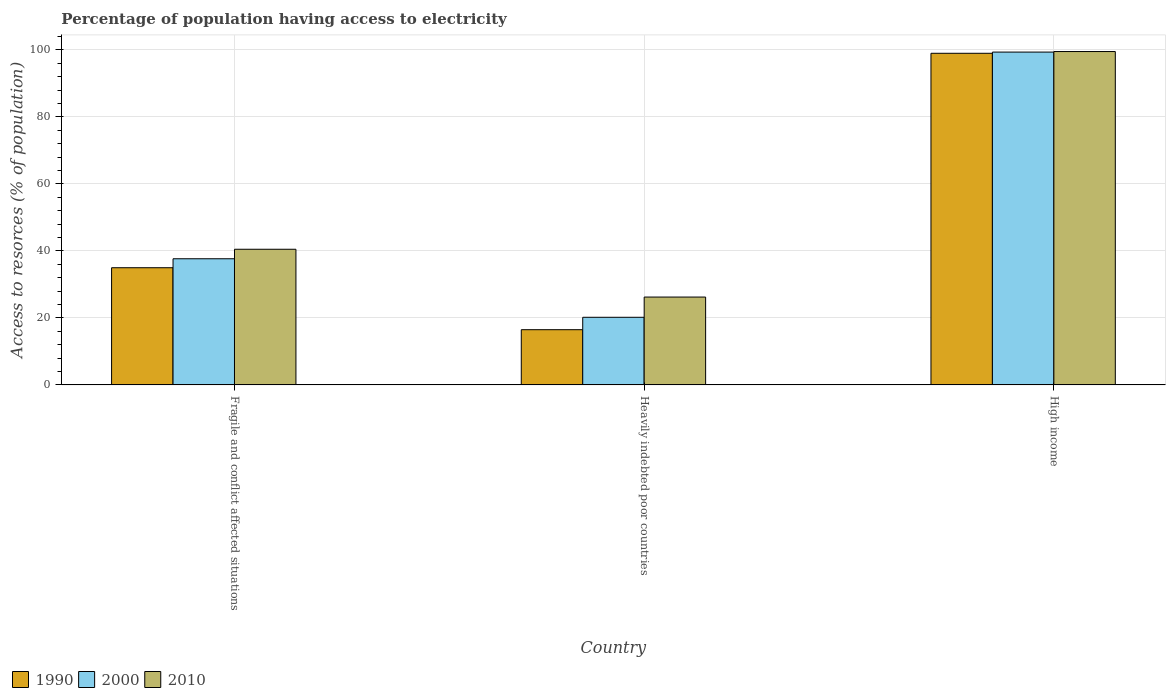How many different coloured bars are there?
Offer a very short reply. 3. How many groups of bars are there?
Provide a succinct answer. 3. Are the number of bars per tick equal to the number of legend labels?
Your answer should be compact. Yes. Are the number of bars on each tick of the X-axis equal?
Provide a short and direct response. Yes. What is the label of the 2nd group of bars from the left?
Offer a very short reply. Heavily indebted poor countries. What is the percentage of population having access to electricity in 2010 in Fragile and conflict affected situations?
Make the answer very short. 40.49. Across all countries, what is the maximum percentage of population having access to electricity in 2000?
Keep it short and to the point. 99.33. Across all countries, what is the minimum percentage of population having access to electricity in 1990?
Keep it short and to the point. 16.48. In which country was the percentage of population having access to electricity in 2000 maximum?
Offer a very short reply. High income. In which country was the percentage of population having access to electricity in 1990 minimum?
Provide a succinct answer. Heavily indebted poor countries. What is the total percentage of population having access to electricity in 1990 in the graph?
Your response must be concise. 150.42. What is the difference between the percentage of population having access to electricity in 1990 in Fragile and conflict affected situations and that in High income?
Your response must be concise. -64. What is the difference between the percentage of population having access to electricity in 2000 in High income and the percentage of population having access to electricity in 2010 in Fragile and conflict affected situations?
Keep it short and to the point. 58.84. What is the average percentage of population having access to electricity in 1990 per country?
Offer a terse response. 50.14. What is the difference between the percentage of population having access to electricity of/in 2010 and percentage of population having access to electricity of/in 1990 in Heavily indebted poor countries?
Your answer should be compact. 9.74. What is the ratio of the percentage of population having access to electricity in 2000 in Heavily indebted poor countries to that in High income?
Your response must be concise. 0.2. What is the difference between the highest and the second highest percentage of population having access to electricity in 2000?
Ensure brevity in your answer.  79.15. What is the difference between the highest and the lowest percentage of population having access to electricity in 2000?
Provide a succinct answer. 79.15. In how many countries, is the percentage of population having access to electricity in 2010 greater than the average percentage of population having access to electricity in 2010 taken over all countries?
Offer a very short reply. 1. What does the 3rd bar from the left in High income represents?
Your response must be concise. 2010. What does the 3rd bar from the right in High income represents?
Your answer should be very brief. 1990. Are all the bars in the graph horizontal?
Your response must be concise. No. Does the graph contain grids?
Offer a terse response. Yes. How many legend labels are there?
Offer a terse response. 3. What is the title of the graph?
Make the answer very short. Percentage of population having access to electricity. What is the label or title of the X-axis?
Your answer should be compact. Country. What is the label or title of the Y-axis?
Ensure brevity in your answer.  Access to resorces (% of population). What is the Access to resorces (% of population) in 1990 in Fragile and conflict affected situations?
Make the answer very short. 34.97. What is the Access to resorces (% of population) of 2000 in Fragile and conflict affected situations?
Offer a terse response. 37.65. What is the Access to resorces (% of population) of 2010 in Fragile and conflict affected situations?
Offer a terse response. 40.49. What is the Access to resorces (% of population) in 1990 in Heavily indebted poor countries?
Provide a short and direct response. 16.48. What is the Access to resorces (% of population) in 2000 in Heavily indebted poor countries?
Your answer should be very brief. 20.18. What is the Access to resorces (% of population) in 2010 in Heavily indebted poor countries?
Offer a terse response. 26.22. What is the Access to resorces (% of population) in 1990 in High income?
Ensure brevity in your answer.  98.97. What is the Access to resorces (% of population) of 2000 in High income?
Give a very brief answer. 99.33. What is the Access to resorces (% of population) of 2010 in High income?
Give a very brief answer. 99.49. Across all countries, what is the maximum Access to resorces (% of population) in 1990?
Provide a short and direct response. 98.97. Across all countries, what is the maximum Access to resorces (% of population) in 2000?
Your response must be concise. 99.33. Across all countries, what is the maximum Access to resorces (% of population) in 2010?
Your answer should be compact. 99.49. Across all countries, what is the minimum Access to resorces (% of population) in 1990?
Your response must be concise. 16.48. Across all countries, what is the minimum Access to resorces (% of population) in 2000?
Offer a very short reply. 20.18. Across all countries, what is the minimum Access to resorces (% of population) in 2010?
Offer a terse response. 26.22. What is the total Access to resorces (% of population) in 1990 in the graph?
Offer a terse response. 150.42. What is the total Access to resorces (% of population) in 2000 in the graph?
Your response must be concise. 157.16. What is the total Access to resorces (% of population) of 2010 in the graph?
Provide a succinct answer. 166.2. What is the difference between the Access to resorces (% of population) of 1990 in Fragile and conflict affected situations and that in Heavily indebted poor countries?
Offer a terse response. 18.49. What is the difference between the Access to resorces (% of population) in 2000 in Fragile and conflict affected situations and that in Heavily indebted poor countries?
Give a very brief answer. 17.46. What is the difference between the Access to resorces (% of population) of 2010 in Fragile and conflict affected situations and that in Heavily indebted poor countries?
Ensure brevity in your answer.  14.27. What is the difference between the Access to resorces (% of population) in 1990 in Fragile and conflict affected situations and that in High income?
Make the answer very short. -64. What is the difference between the Access to resorces (% of population) of 2000 in Fragile and conflict affected situations and that in High income?
Offer a terse response. -61.68. What is the difference between the Access to resorces (% of population) in 2010 in Fragile and conflict affected situations and that in High income?
Offer a terse response. -59.01. What is the difference between the Access to resorces (% of population) in 1990 in Heavily indebted poor countries and that in High income?
Offer a very short reply. -82.49. What is the difference between the Access to resorces (% of population) in 2000 in Heavily indebted poor countries and that in High income?
Ensure brevity in your answer.  -79.15. What is the difference between the Access to resorces (% of population) of 2010 in Heavily indebted poor countries and that in High income?
Keep it short and to the point. -73.27. What is the difference between the Access to resorces (% of population) of 1990 in Fragile and conflict affected situations and the Access to resorces (% of population) of 2000 in Heavily indebted poor countries?
Offer a terse response. 14.79. What is the difference between the Access to resorces (% of population) of 1990 in Fragile and conflict affected situations and the Access to resorces (% of population) of 2010 in Heavily indebted poor countries?
Offer a very short reply. 8.75. What is the difference between the Access to resorces (% of population) in 2000 in Fragile and conflict affected situations and the Access to resorces (% of population) in 2010 in Heavily indebted poor countries?
Give a very brief answer. 11.43. What is the difference between the Access to resorces (% of population) of 1990 in Fragile and conflict affected situations and the Access to resorces (% of population) of 2000 in High income?
Ensure brevity in your answer.  -64.36. What is the difference between the Access to resorces (% of population) of 1990 in Fragile and conflict affected situations and the Access to resorces (% of population) of 2010 in High income?
Give a very brief answer. -64.52. What is the difference between the Access to resorces (% of population) of 2000 in Fragile and conflict affected situations and the Access to resorces (% of population) of 2010 in High income?
Provide a succinct answer. -61.85. What is the difference between the Access to resorces (% of population) in 1990 in Heavily indebted poor countries and the Access to resorces (% of population) in 2000 in High income?
Ensure brevity in your answer.  -82.85. What is the difference between the Access to resorces (% of population) in 1990 in Heavily indebted poor countries and the Access to resorces (% of population) in 2010 in High income?
Provide a short and direct response. -83.01. What is the difference between the Access to resorces (% of population) in 2000 in Heavily indebted poor countries and the Access to resorces (% of population) in 2010 in High income?
Your answer should be compact. -79.31. What is the average Access to resorces (% of population) of 1990 per country?
Offer a terse response. 50.14. What is the average Access to resorces (% of population) of 2000 per country?
Ensure brevity in your answer.  52.39. What is the average Access to resorces (% of population) in 2010 per country?
Your response must be concise. 55.4. What is the difference between the Access to resorces (% of population) of 1990 and Access to resorces (% of population) of 2000 in Fragile and conflict affected situations?
Offer a very short reply. -2.68. What is the difference between the Access to resorces (% of population) of 1990 and Access to resorces (% of population) of 2010 in Fragile and conflict affected situations?
Your response must be concise. -5.51. What is the difference between the Access to resorces (% of population) in 2000 and Access to resorces (% of population) in 2010 in Fragile and conflict affected situations?
Your answer should be very brief. -2.84. What is the difference between the Access to resorces (% of population) of 1990 and Access to resorces (% of population) of 2000 in Heavily indebted poor countries?
Give a very brief answer. -3.7. What is the difference between the Access to resorces (% of population) in 1990 and Access to resorces (% of population) in 2010 in Heavily indebted poor countries?
Provide a succinct answer. -9.74. What is the difference between the Access to resorces (% of population) of 2000 and Access to resorces (% of population) of 2010 in Heavily indebted poor countries?
Ensure brevity in your answer.  -6.04. What is the difference between the Access to resorces (% of population) of 1990 and Access to resorces (% of population) of 2000 in High income?
Provide a short and direct response. -0.36. What is the difference between the Access to resorces (% of population) of 1990 and Access to resorces (% of population) of 2010 in High income?
Give a very brief answer. -0.52. What is the difference between the Access to resorces (% of population) in 2000 and Access to resorces (% of population) in 2010 in High income?
Your answer should be compact. -0.16. What is the ratio of the Access to resorces (% of population) in 1990 in Fragile and conflict affected situations to that in Heavily indebted poor countries?
Your response must be concise. 2.12. What is the ratio of the Access to resorces (% of population) of 2000 in Fragile and conflict affected situations to that in Heavily indebted poor countries?
Give a very brief answer. 1.87. What is the ratio of the Access to resorces (% of population) in 2010 in Fragile and conflict affected situations to that in Heavily indebted poor countries?
Give a very brief answer. 1.54. What is the ratio of the Access to resorces (% of population) in 1990 in Fragile and conflict affected situations to that in High income?
Ensure brevity in your answer.  0.35. What is the ratio of the Access to resorces (% of population) in 2000 in Fragile and conflict affected situations to that in High income?
Give a very brief answer. 0.38. What is the ratio of the Access to resorces (% of population) of 2010 in Fragile and conflict affected situations to that in High income?
Keep it short and to the point. 0.41. What is the ratio of the Access to resorces (% of population) in 1990 in Heavily indebted poor countries to that in High income?
Provide a succinct answer. 0.17. What is the ratio of the Access to resorces (% of population) of 2000 in Heavily indebted poor countries to that in High income?
Offer a terse response. 0.2. What is the ratio of the Access to resorces (% of population) of 2010 in Heavily indebted poor countries to that in High income?
Offer a very short reply. 0.26. What is the difference between the highest and the second highest Access to resorces (% of population) of 1990?
Make the answer very short. 64. What is the difference between the highest and the second highest Access to resorces (% of population) in 2000?
Provide a succinct answer. 61.68. What is the difference between the highest and the second highest Access to resorces (% of population) of 2010?
Your answer should be very brief. 59.01. What is the difference between the highest and the lowest Access to resorces (% of population) of 1990?
Offer a very short reply. 82.49. What is the difference between the highest and the lowest Access to resorces (% of population) of 2000?
Provide a succinct answer. 79.15. What is the difference between the highest and the lowest Access to resorces (% of population) in 2010?
Keep it short and to the point. 73.27. 